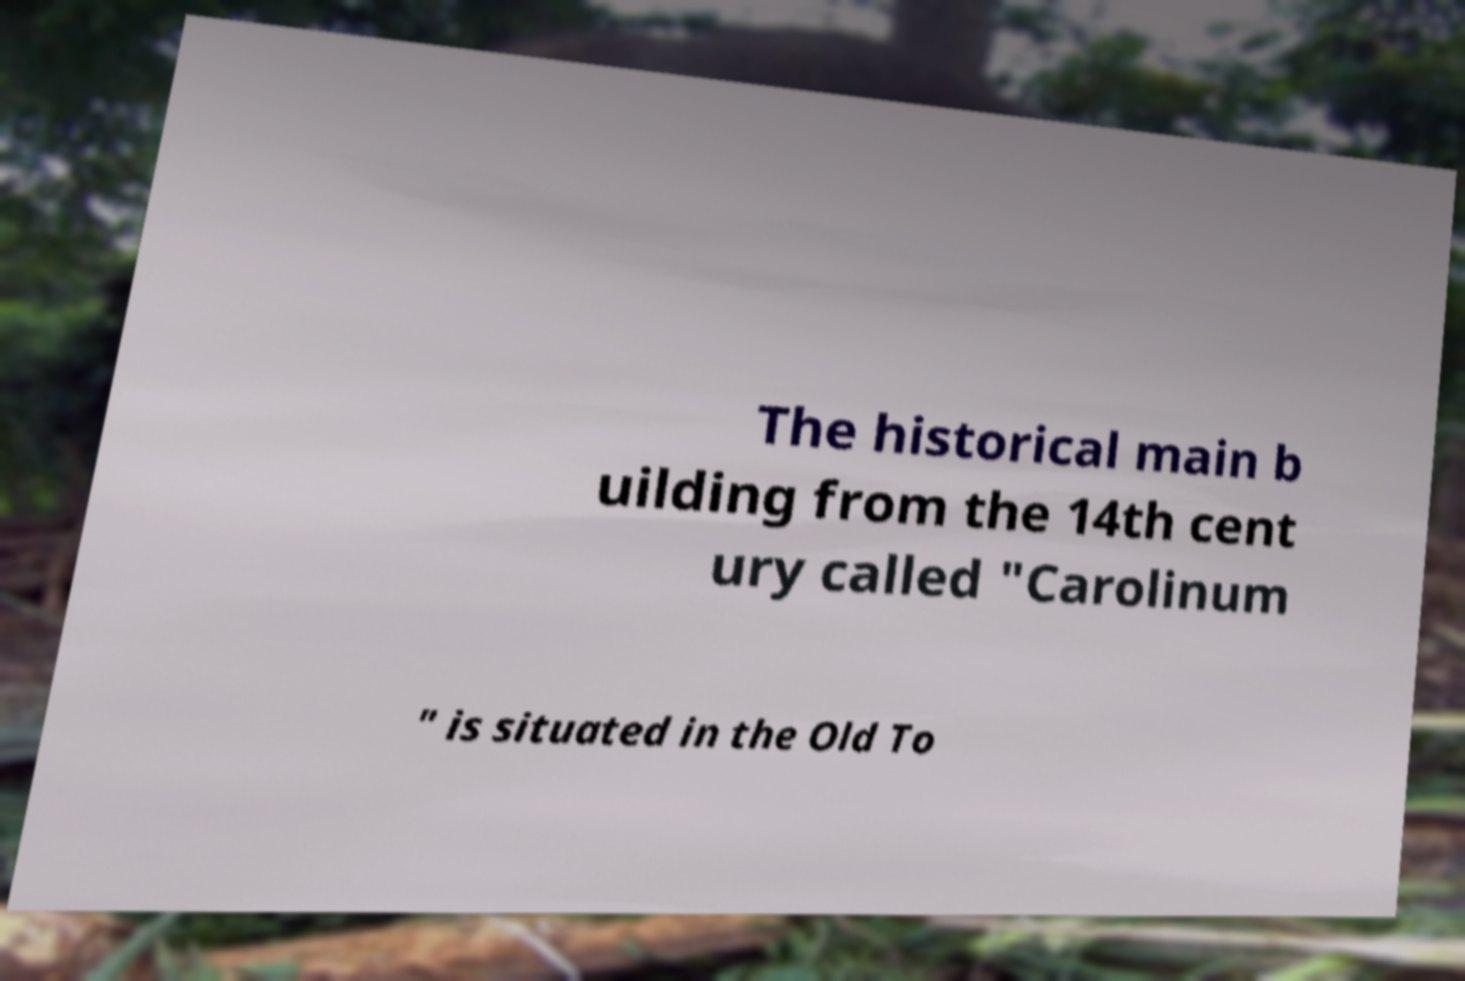Can you read and provide the text displayed in the image?This photo seems to have some interesting text. Can you extract and type it out for me? The historical main b uilding from the 14th cent ury called "Carolinum " is situated in the Old To 